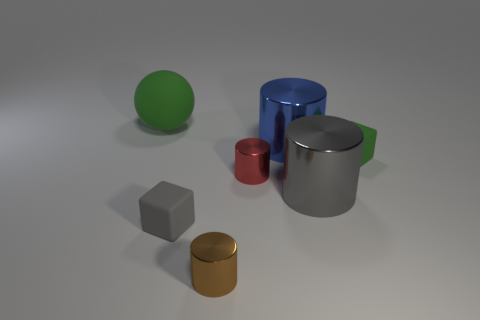There is a large blue metal cylinder; are there any red things to the right of it? no 